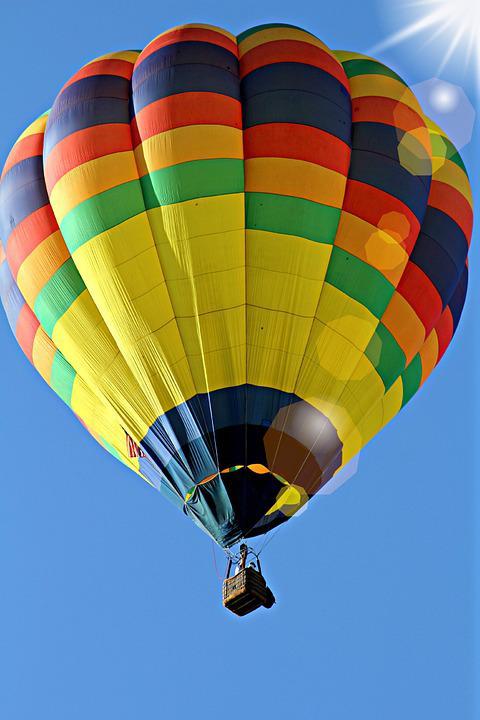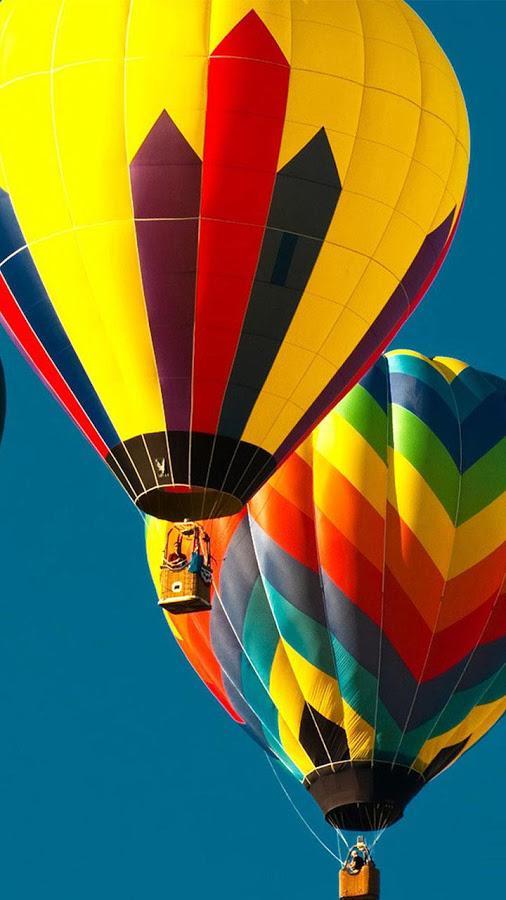The first image is the image on the left, the second image is the image on the right. Evaluate the accuracy of this statement regarding the images: "There are exactly 2 flying balloons.". Is it true? Answer yes or no. No. The first image is the image on the left, the second image is the image on the right. Assess this claim about the two images: "In total, two hot-air balloons are shown, each floating in the air.". Correct or not? Answer yes or no. No. 